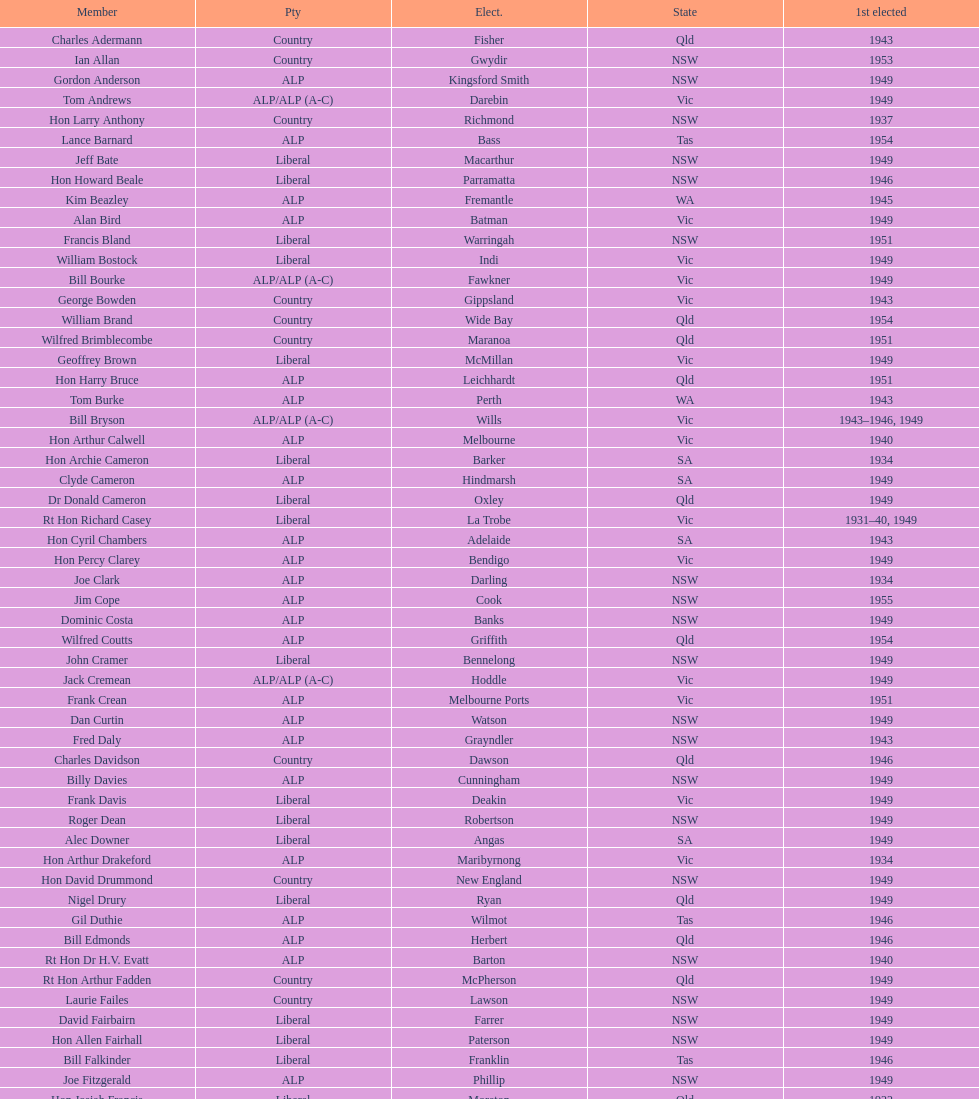When was joe clark first elected? 1934. 